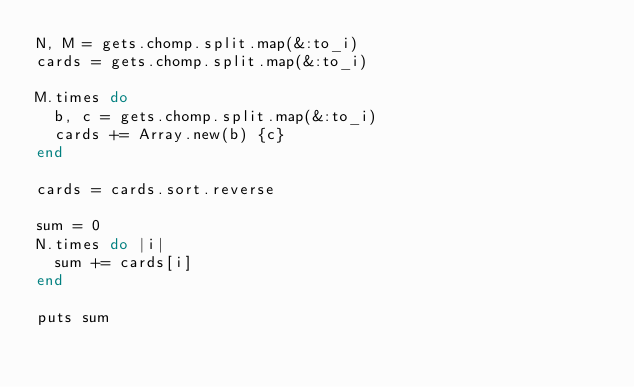<code> <loc_0><loc_0><loc_500><loc_500><_Ruby_>N, M = gets.chomp.split.map(&:to_i)
cards = gets.chomp.split.map(&:to_i)

M.times do
  b, c = gets.chomp.split.map(&:to_i)
  cards += Array.new(b) {c}
end

cards = cards.sort.reverse

sum = 0
N.times do |i|
  sum += cards[i]
end

puts sum
</code> 